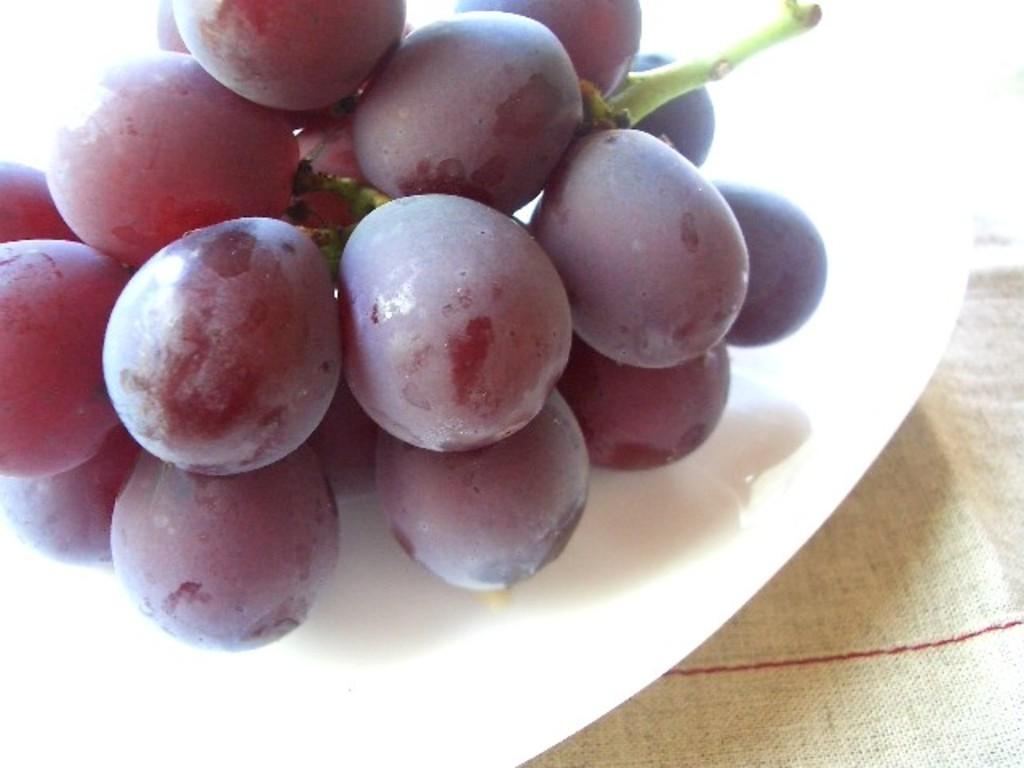What is on the plate that is visible in the image? There are grapes on the plate in the image. What is located at the bottom of the image? There is a mat at the bottom of the image. Where is the kettle placed in the image? There is no kettle present in the image. What type of bottle can be seen on the shelf in the image? There is no shelf or bottle present in the image. 